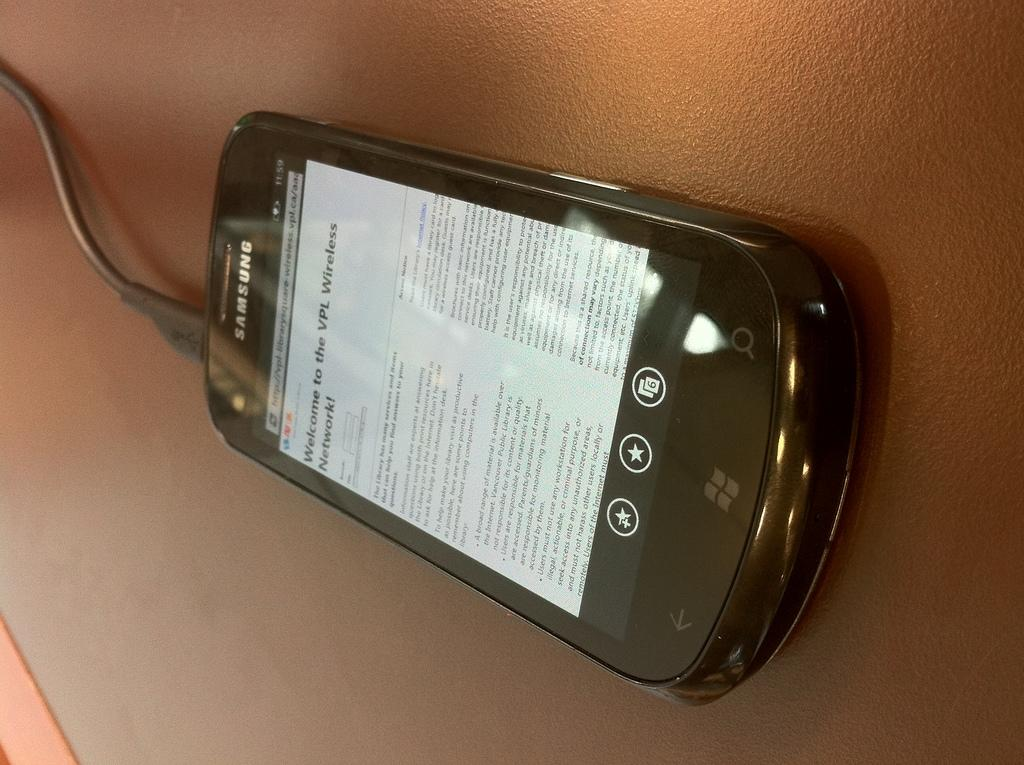Provide a one-sentence caption for the provided image. a Samsung phone with a screen about a wireless network. 